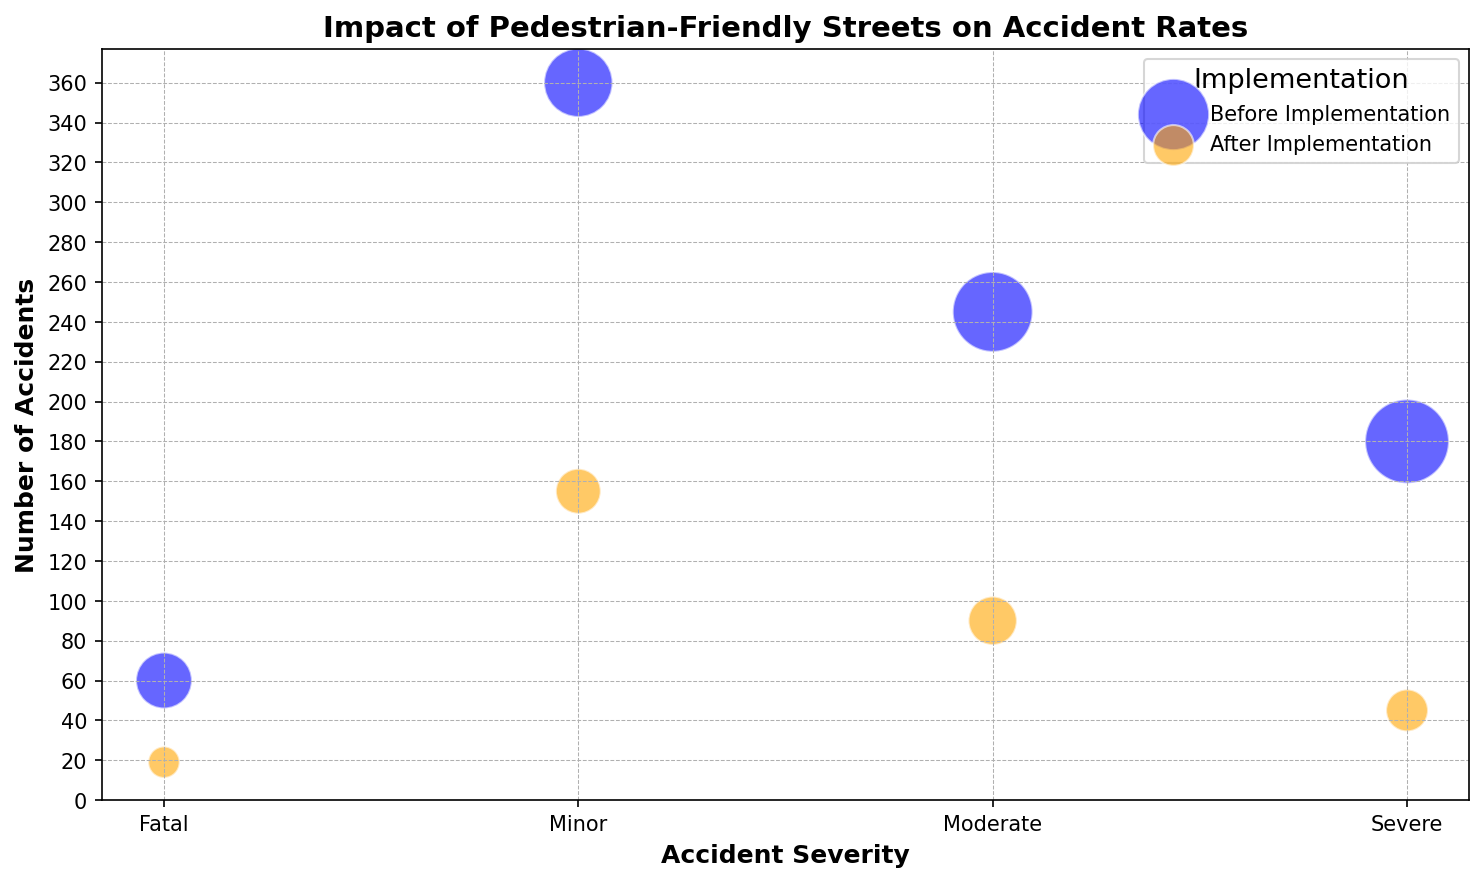How many minor accidents were reported before and after the implementation combined? First, identify the number of minor accidents reported before implementation, which is the combined value of all 'Before Implementation' entries for 'Minor' severity: 120 + 110 + 130 = 360. Next, identify the number of minor accidents reported after implementation, which is the combined value of all 'After Implementation' entries for 'Minor' severity: 45 + 50 + 60 = 155. Finally, add these two results together: 360 + 155 = 515.
Answer: 515 Comparing severe and fatal accidents, which saw a greater reduction in the number of accidents after implementation? First, calculate the reduction for severe accidents: (65 + 55 + 60) - (15 + 12 + 18) = 180 - 45 = 135. Next, calculate the reduction for fatal accidents: (20 + 15 + 25) - (5 + 4 + 10) = 60 - 19 = 41. Comparing these reductions, severe accidents saw a greater reduction: 135 > 41.
Answer: Severe What is the difference in the number of fatal accidents before and after implementation? Calculate the total number of fatal accidents before implementation by summing the 'Before Implementation' entries for 'Fatal': 20 + 15 + 25 = 60. Similarly, sum the numbers for 'After Implementation': 5 + 4 + 10 = 19. Subtract the total after from before: 60 - 19 = 41.
Answer: 41 How does the number of moderate accidents after implementation compare to severe accidents before implementation? Sum the numbers for moderate accidents after implementation: 30 + 25 + 35 = 90. Then sum the numbers for severe accidents before implementation: 65 + 55 + 60 = 180. Compare these sums: 90 after is less than 180 before.
Answer: Less Which category of accidents saw the largest drop in numbers after implementation? Calculate the differences between before and after implementation numbers for all categories: Minor: (120 + 110 + 130) - (45 + 50 + 60) = 360 - 155 = 205; Moderate: (85 + 70 + 90) - (30 + 25 + 35) = 245 - 90 = 155; Severe: (65 + 55 + 60) - (15 + 12 + 18) = 180 - 45 = 135; Fatal: (20 + 15 + 25) - (5 + 4 + 10) = 60 - 19 = 41. The largest drop is in the 'Minor' category with 205.
Answer: Minor What trend is visible in the number of accidents when comparing before and after implementation for all severity categories? Visually, it is clear that the number of accidents drops in each category after the implementation of pedestrian-friendly streets. Minor accidents decrease significantly, moderate and severe also drop noticeably, and fatal accidents show the least reduction visually but still a decline.
Answer: Declining trend 